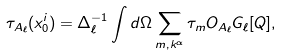Convert formula to latex. <formula><loc_0><loc_0><loc_500><loc_500>\tau _ { A _ { \ell } } ( x _ { 0 } ^ { i } ) = \Delta _ { \ell } ^ { - 1 } \int d \Omega \sum _ { m , k ^ { \alpha } } \tau _ { m } O _ { A _ { \ell } } G _ { \ell } [ Q ] ,</formula> 